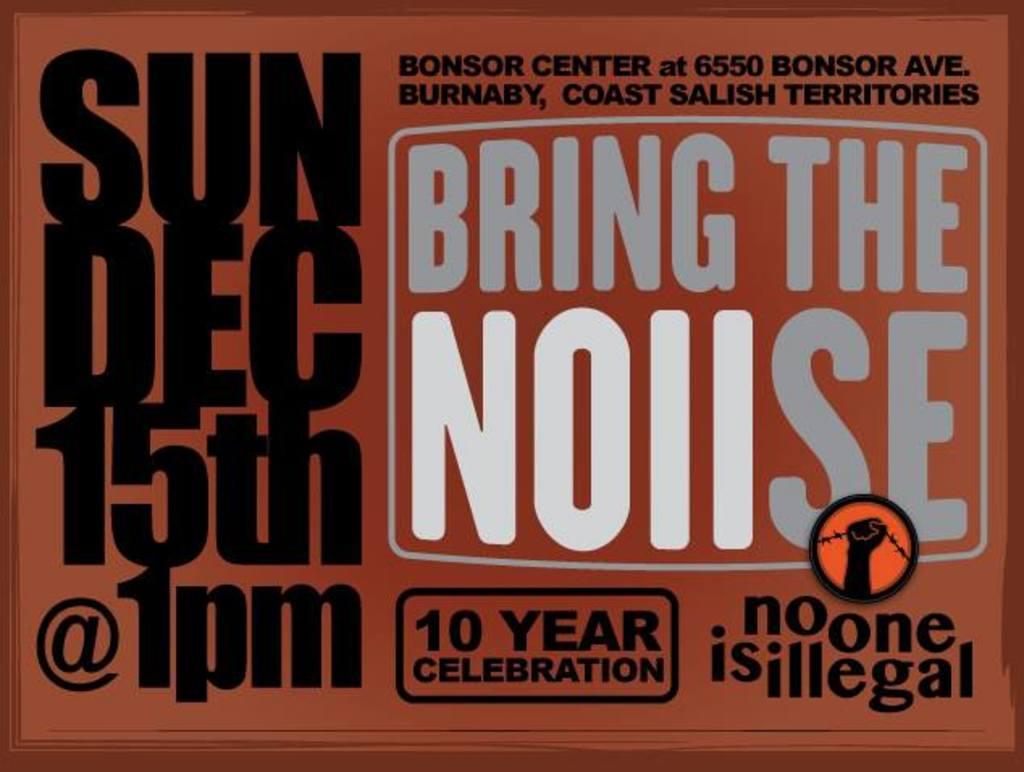When is this taking place?
Make the answer very short. Dec 15th @ 1pm. No one is what?
Ensure brevity in your answer.  Illegal. 